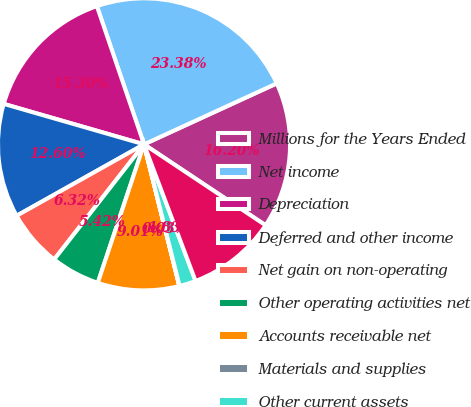Convert chart to OTSL. <chart><loc_0><loc_0><loc_500><loc_500><pie_chart><fcel>Millions for the Years Ended<fcel>Net income<fcel>Depreciation<fcel>Deferred and other income<fcel>Net gain on non-operating<fcel>Other operating activities net<fcel>Accounts receivable net<fcel>Materials and supplies<fcel>Other current assets<fcel>Accounts payable and other<nl><fcel>16.2%<fcel>23.38%<fcel>15.3%<fcel>12.6%<fcel>6.32%<fcel>5.42%<fcel>9.01%<fcel>0.03%<fcel>1.83%<fcel>9.91%<nl></chart> 